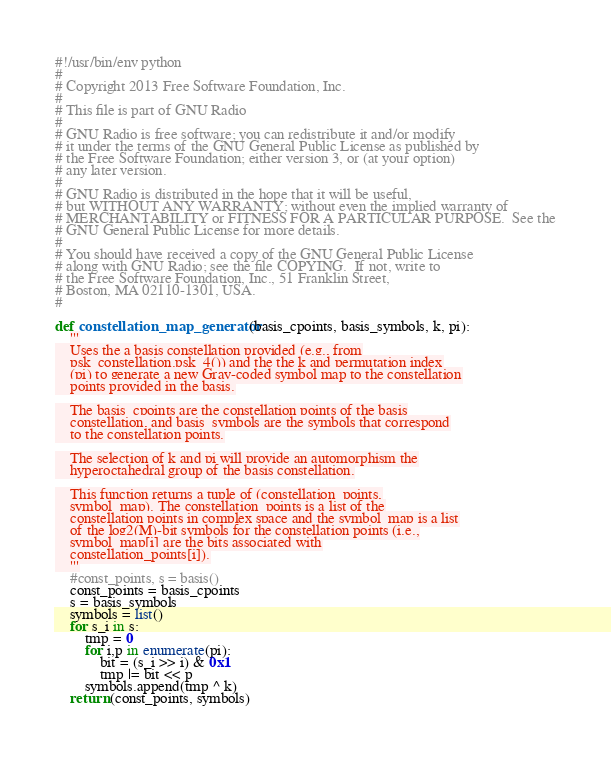<code> <loc_0><loc_0><loc_500><loc_500><_Python_>#!/usr/bin/env python
#
# Copyright 2013 Free Software Foundation, Inc.
#
# This file is part of GNU Radio
#
# GNU Radio is free software; you can redistribute it and/or modify
# it under the terms of the GNU General Public License as published by
# the Free Software Foundation; either version 3, or (at your option)
# any later version.
#
# GNU Radio is distributed in the hope that it will be useful,
# but WITHOUT ANY WARRANTY; without even the implied warranty of
# MERCHANTABILITY or FITNESS FOR A PARTICULAR PURPOSE.  See the
# GNU General Public License for more details.
#
# You should have received a copy of the GNU General Public License
# along with GNU Radio; see the file COPYING.  If not, write to
# the Free Software Foundation, Inc., 51 Franklin Street,
# Boston, MA 02110-1301, USA.
#

def constellation_map_generator(basis_cpoints, basis_symbols, k, pi):
    '''
    Uses the a basis constellation provided (e.g., from
    psk_constellation.psk_4()) and the the k and permutation index
    (pi) to generate a new Gray-coded symbol map to the constellation
    points provided in the basis.

    The basis_cpoints are the constellation points of the basis
    constellation, and basis_symbols are the symbols that correspond
    to the constellation points.

    The selection of k and pi will provide an automorphism the
    hyperoctahedral group of the basis constellation.

    This function returns a tuple of (constellation_points,
    symbol_map). The constellation_points is a list of the
    constellation points in complex space and the symbol_map is a list
    of the log2(M)-bit symbols for the constellation points (i.e.,
    symbol_map[i] are the bits associated with
    constellation_points[i]).
    '''
    #const_points, s = basis()
    const_points = basis_cpoints
    s = basis_symbols
    symbols = list()
    for s_i in s:
        tmp = 0
        for i,p in enumerate(pi):
            bit = (s_i >> i) & 0x1
            tmp |= bit << p
        symbols.append(tmp ^ k)
    return (const_points, symbols)
</code> 